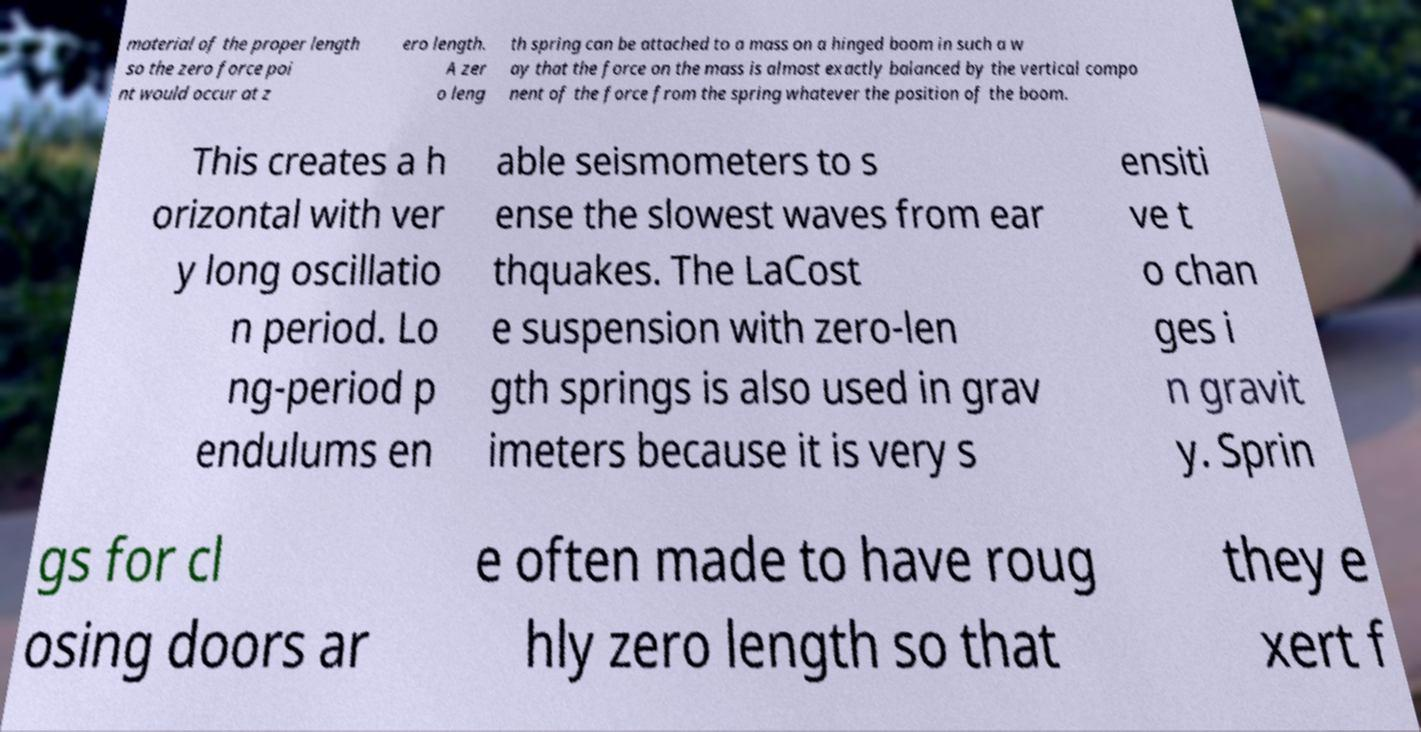Please read and relay the text visible in this image. What does it say? material of the proper length so the zero force poi nt would occur at z ero length. A zer o leng th spring can be attached to a mass on a hinged boom in such a w ay that the force on the mass is almost exactly balanced by the vertical compo nent of the force from the spring whatever the position of the boom. This creates a h orizontal with ver y long oscillatio n period. Lo ng-period p endulums en able seismometers to s ense the slowest waves from ear thquakes. The LaCost e suspension with zero-len gth springs is also used in grav imeters because it is very s ensiti ve t o chan ges i n gravit y. Sprin gs for cl osing doors ar e often made to have roug hly zero length so that they e xert f 